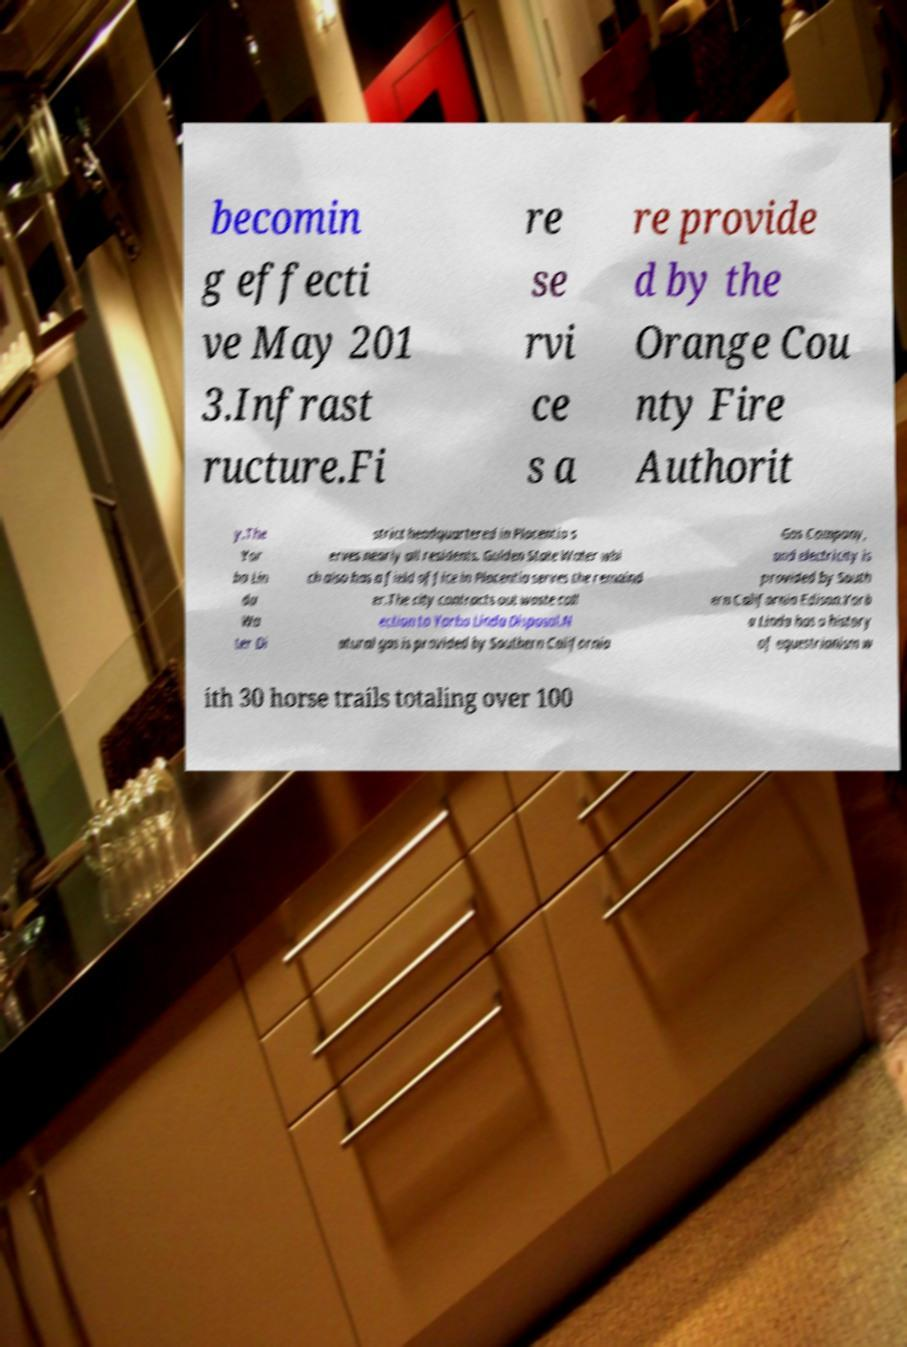For documentation purposes, I need the text within this image transcribed. Could you provide that? becomin g effecti ve May 201 3.Infrast ructure.Fi re se rvi ce s a re provide d by the Orange Cou nty Fire Authorit y.The Yor ba Lin da Wa ter Di strict headquartered in Placentia s erves nearly all residents. Golden State Water whi ch also has a field office in Placentia serves the remaind er.The city contracts out waste coll ection to Yorba Linda Disposal.N atural gas is provided by Southern California Gas Company, and electricity is provided by South ern California Edison.Yorb a Linda has a history of equestrianism w ith 30 horse trails totaling over 100 